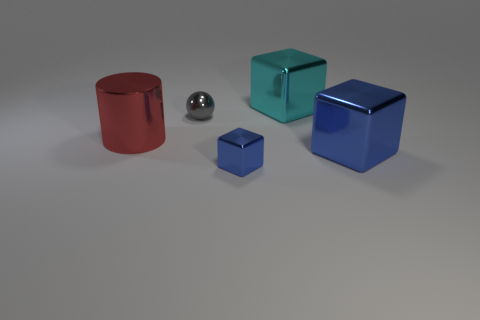Subtract 1 blocks. How many blocks are left? 2 Add 1 tiny blue cubes. How many objects exist? 6 Subtract all cylinders. How many objects are left? 4 Subtract 0 brown balls. How many objects are left? 5 Subtract all big cylinders. Subtract all big purple cylinders. How many objects are left? 4 Add 2 cyan objects. How many cyan objects are left? 3 Add 1 small purple cylinders. How many small purple cylinders exist? 1 